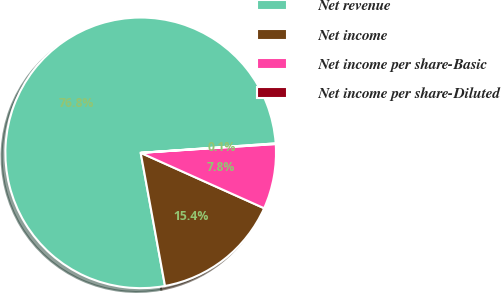Convert chart to OTSL. <chart><loc_0><loc_0><loc_500><loc_500><pie_chart><fcel>Net revenue<fcel>Net income<fcel>Net income per share-Basic<fcel>Net income per share-Diluted<nl><fcel>76.76%<fcel>15.41%<fcel>7.75%<fcel>0.08%<nl></chart> 